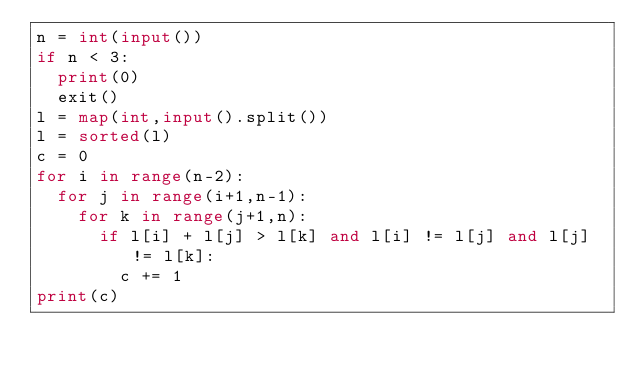<code> <loc_0><loc_0><loc_500><loc_500><_Python_>n = int(input())
if n < 3:
  print(0)
  exit()
l = map(int,input().split())
l = sorted(l)
c = 0
for i in range(n-2):
  for j in range(i+1,n-1):
    for k in range(j+1,n):
      if l[i] + l[j] > l[k] and l[i] != l[j] and l[j] != l[k]:
        c += 1
print(c)
</code> 